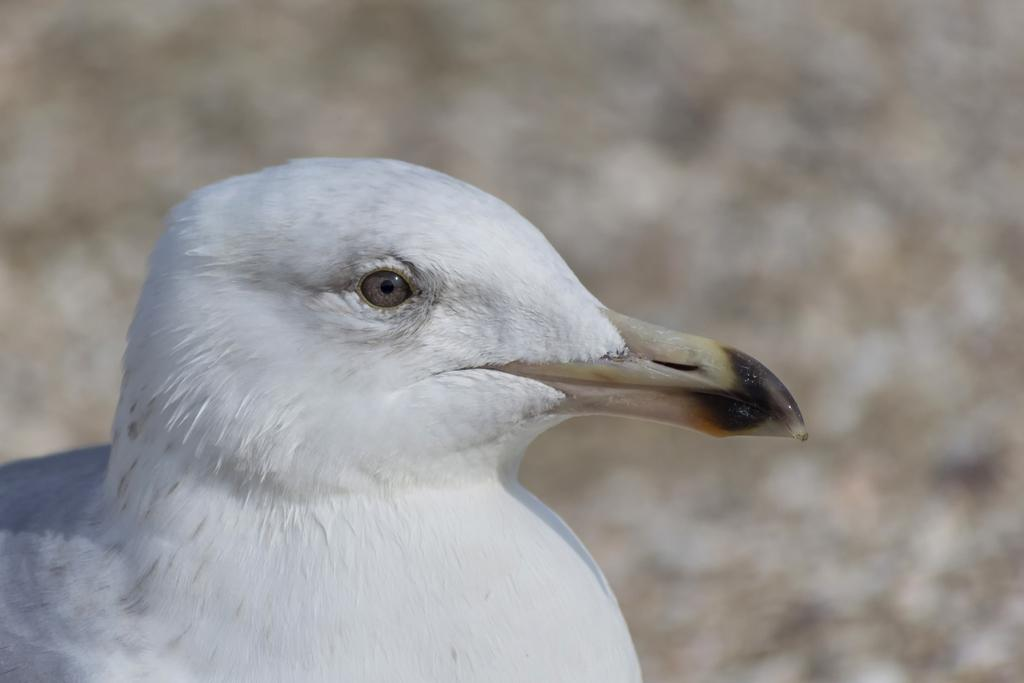What type of animal is in the image? There is a bird in the image. Can you describe the perspective of the image? The image provides a close-up view of the bird. What type of suit is the bird wearing in the image? Birds do not wear suits, so there is no suit present in the image. 